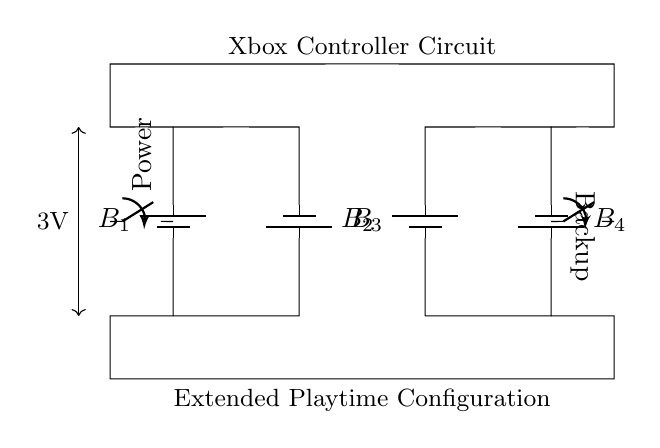What is the total number of batteries in this circuit? There are four batteries labelled as B1, B2, B3, and B4, which are arranged in parallel.
Answer: 4 What type of configuration is represented in the circuit? The circuit shows a parallel configuration, as all batteries are connected alongside each other, sharing both the positive and the negative terminals.
Answer: Parallel What is the voltage across the batteries? The circuit indicates that the voltage across the parallel batteries is 3V, which is provided at the indicated height in the diagram.
Answer: 3V What is the purpose of the switches in this circuit? The switches allow you to control the flow of power to the circuit; one switch is for power and the other for backup, providing flexibility in playtime management.
Answer: Control power How would the total capacity change if one battery fails? Even if one battery were to fail, the remaining batteries would continue to function, maintaining connection and voltage at 3V, so the total capacity of the circuit remains sufficient for extended playtime.
Answer: Remains sufficient What is the implication of using a parallel configuration for battery connection? Using a parallel configuration allows for an extended playtime since the capacity in terms of amp-hours increases while maintaining the same voltage, which is crucial for longer gaming sessions.
Answer: Extended playtime 